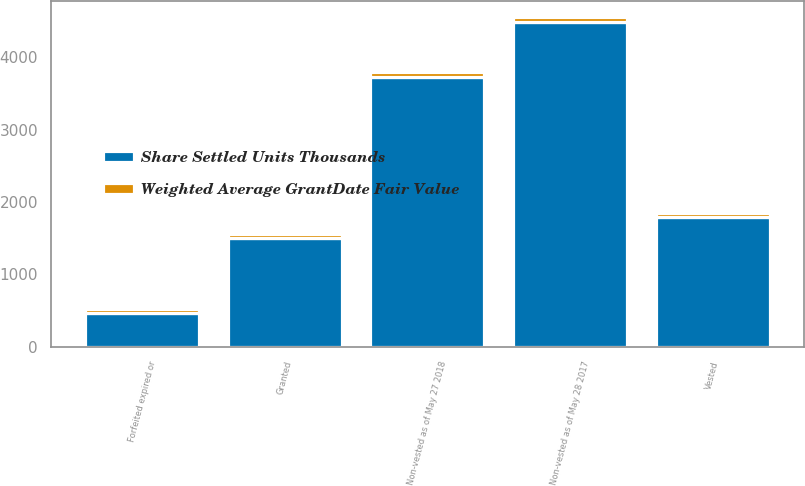Convert chart to OTSL. <chart><loc_0><loc_0><loc_500><loc_500><stacked_bar_chart><ecel><fcel>Non-vested as of May 28 2017<fcel>Granted<fcel>Vested<fcel>Forfeited expired or<fcel>Non-vested as of May 27 2018<nl><fcel>Share Settled Units Thousands<fcel>4491.2<fcel>1505.7<fcel>1798.8<fcel>466.3<fcel>3731.8<nl><fcel>Weighted Average GrantDate Fair Value<fcel>56.08<fcel>55.11<fcel>50.73<fcel>62.19<fcel>57.5<nl></chart> 